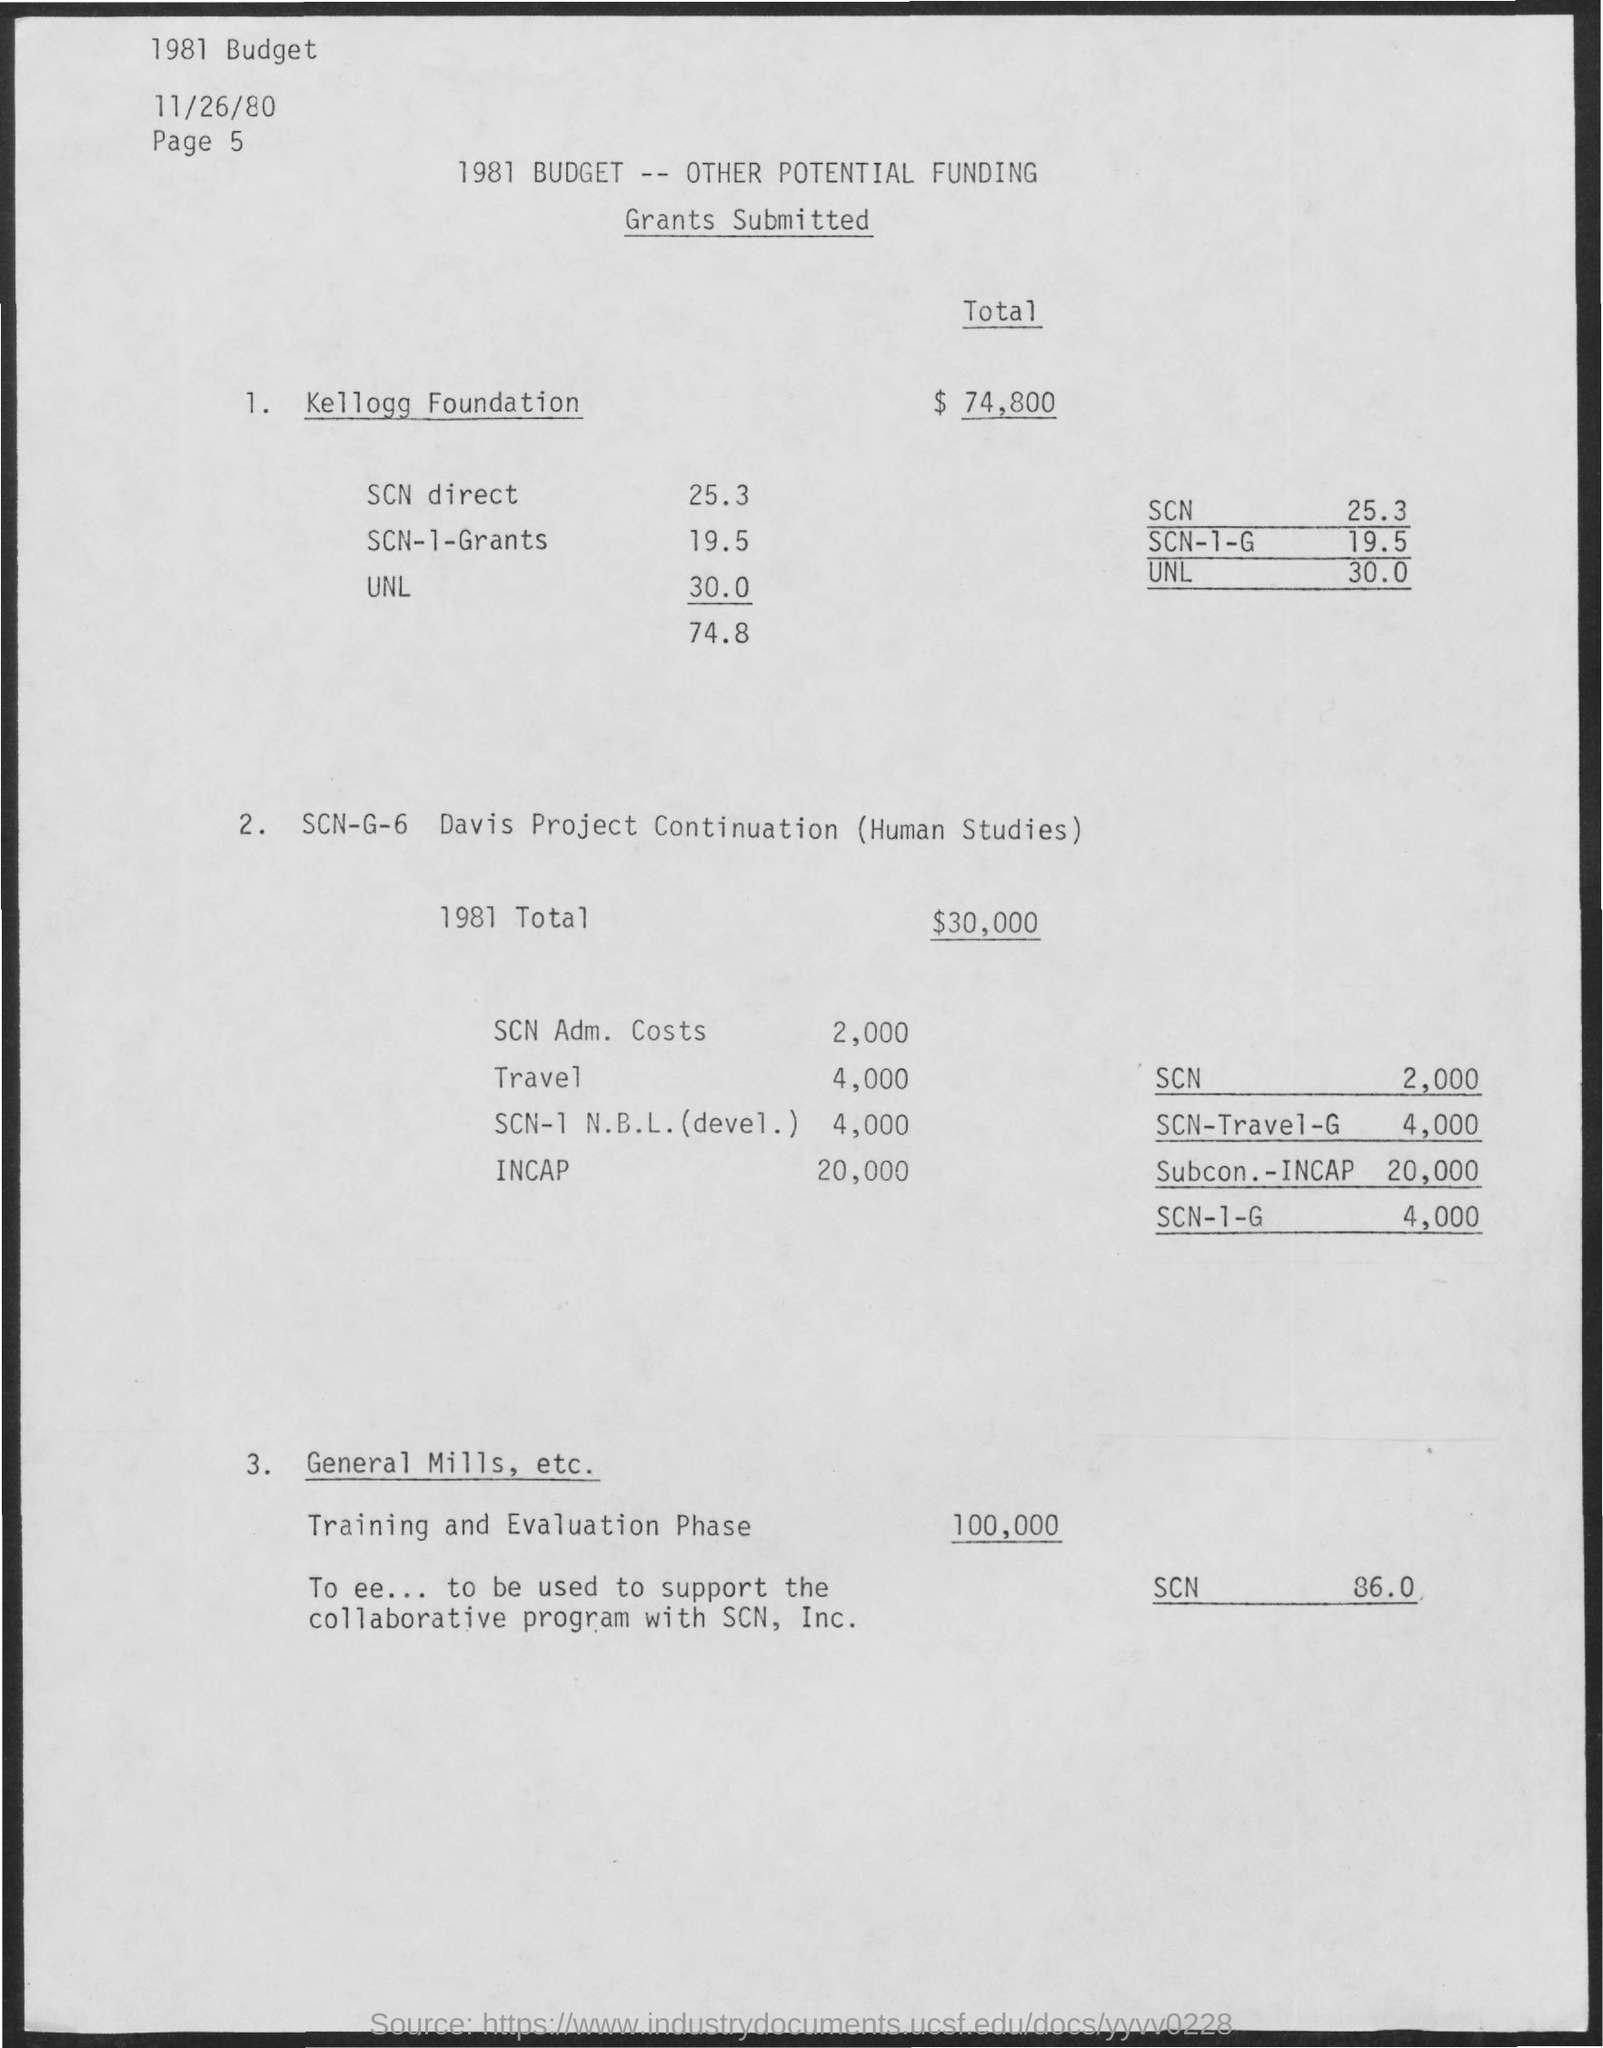Is there any information about other grants or funding sources other than those listed? While the document provides figures for grants from the Kellogg Foundation, SCN-G-6 Davis Project Continuation, and General Mills, it does not list additional grants or funding sources beyond these. Further information might be available on other pages or in related documents. 